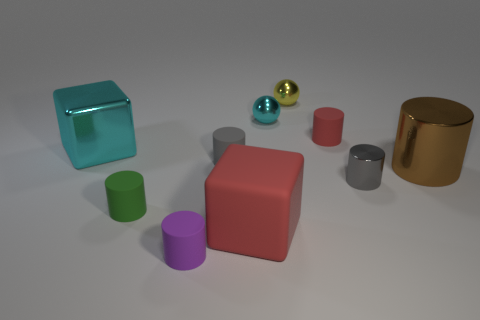What material is the thing that is the same color as the metal cube?
Offer a terse response. Metal. There is a cyan shiny object left of the purple matte cylinder; does it have the same shape as the red rubber object that is on the left side of the small red rubber object?
Provide a short and direct response. Yes. How many blocks are small red shiny objects or tiny yellow objects?
Provide a short and direct response. 0. Are there fewer small cylinders in front of the small red matte thing than shiny things?
Your response must be concise. Yes. How many other things are the same material as the big brown object?
Provide a short and direct response. 4. Does the purple rubber cylinder have the same size as the yellow metallic object?
Make the answer very short. Yes. What number of objects are tiny cylinders right of the purple matte thing or yellow rubber objects?
Your response must be concise. 3. The small gray object that is left of the cyan shiny object right of the big shiny block is made of what material?
Provide a succinct answer. Rubber. Are there any small gray metallic objects of the same shape as the big red rubber object?
Offer a very short reply. No. There is a gray shiny thing; is its size the same as the metal sphere that is on the right side of the cyan metal sphere?
Your answer should be compact. Yes. 